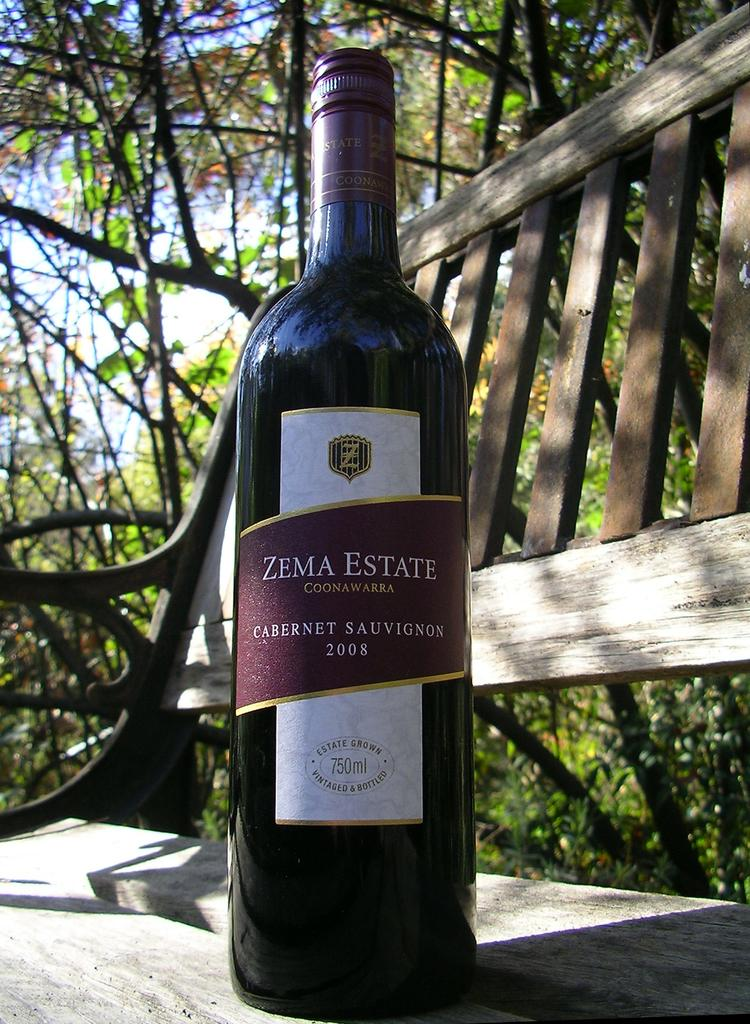<image>
Render a clear and concise summary of the photo. the word zema estate that is on a bottle 